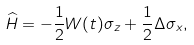Convert formula to latex. <formula><loc_0><loc_0><loc_500><loc_500>\widehat { H } = - \frac { 1 } { 2 } W ( t ) \sigma _ { z } + \frac { 1 } { 2 } \Delta \sigma _ { x } ,</formula> 